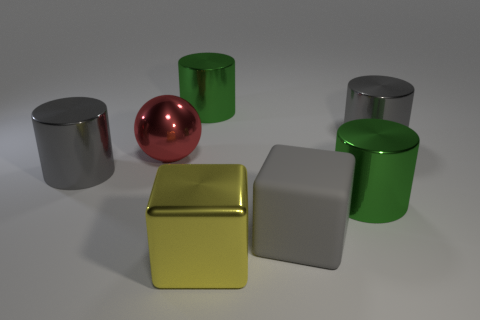What is the size of the other thing that is the same shape as the large rubber object?
Ensure brevity in your answer.  Large. There is a cylinder that is on the right side of the yellow metal thing and in front of the large red metallic thing; what material is it made of?
Provide a short and direct response. Metal. Does the cylinder that is to the left of the ball have the same color as the large matte block?
Provide a succinct answer. Yes. There is a large matte object; is its color the same as the large shiny thing that is left of the large red thing?
Provide a short and direct response. Yes. Are there any large metallic balls right of the metallic block?
Offer a very short reply. No. Does the red sphere have the same material as the large yellow object?
Your response must be concise. Yes. There is a red object that is the same size as the gray cube; what material is it?
Your answer should be compact. Metal. What number of things are either large metallic things that are behind the large red ball or gray rubber spheres?
Your response must be concise. 2. Is the number of metal objects behind the gray rubber thing the same as the number of yellow metallic cubes?
Provide a succinct answer. No. Does the rubber cube have the same color as the metallic block?
Offer a very short reply. No. 